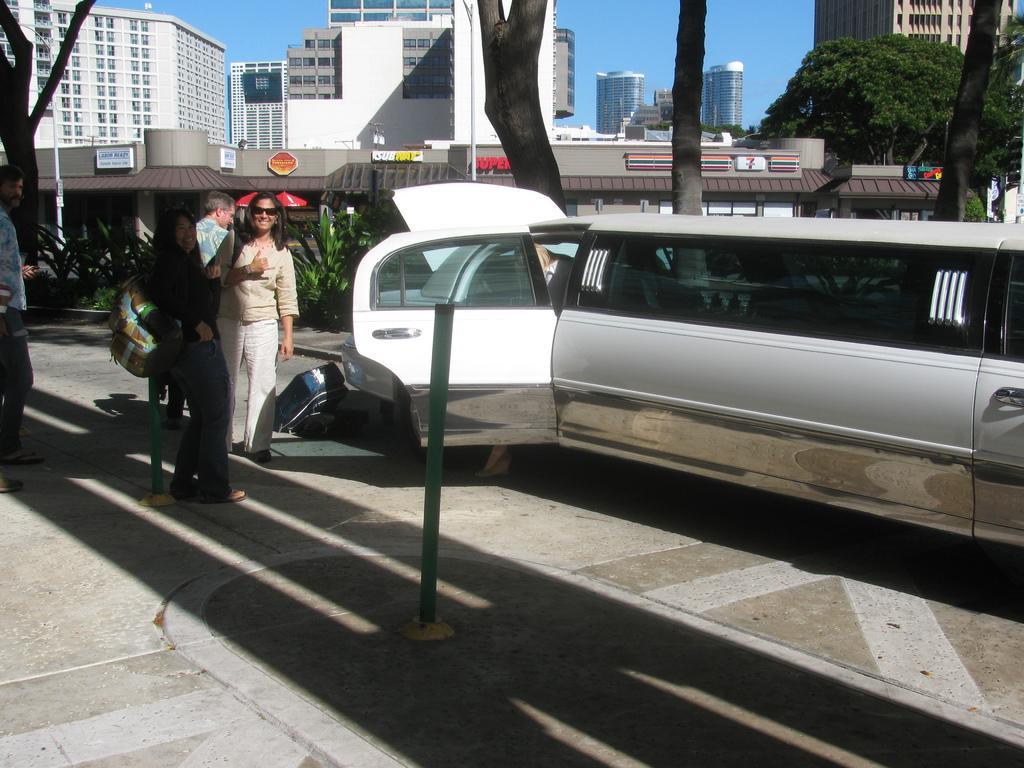Could you give a brief overview of what you see in this image? In the foreground of this image, on the right, there is a vehicle, few bollards, persons wearing backpacks are standing on the pavement and there is also a bag on the ground. In the background, there are few buildings, trees and the sky. 